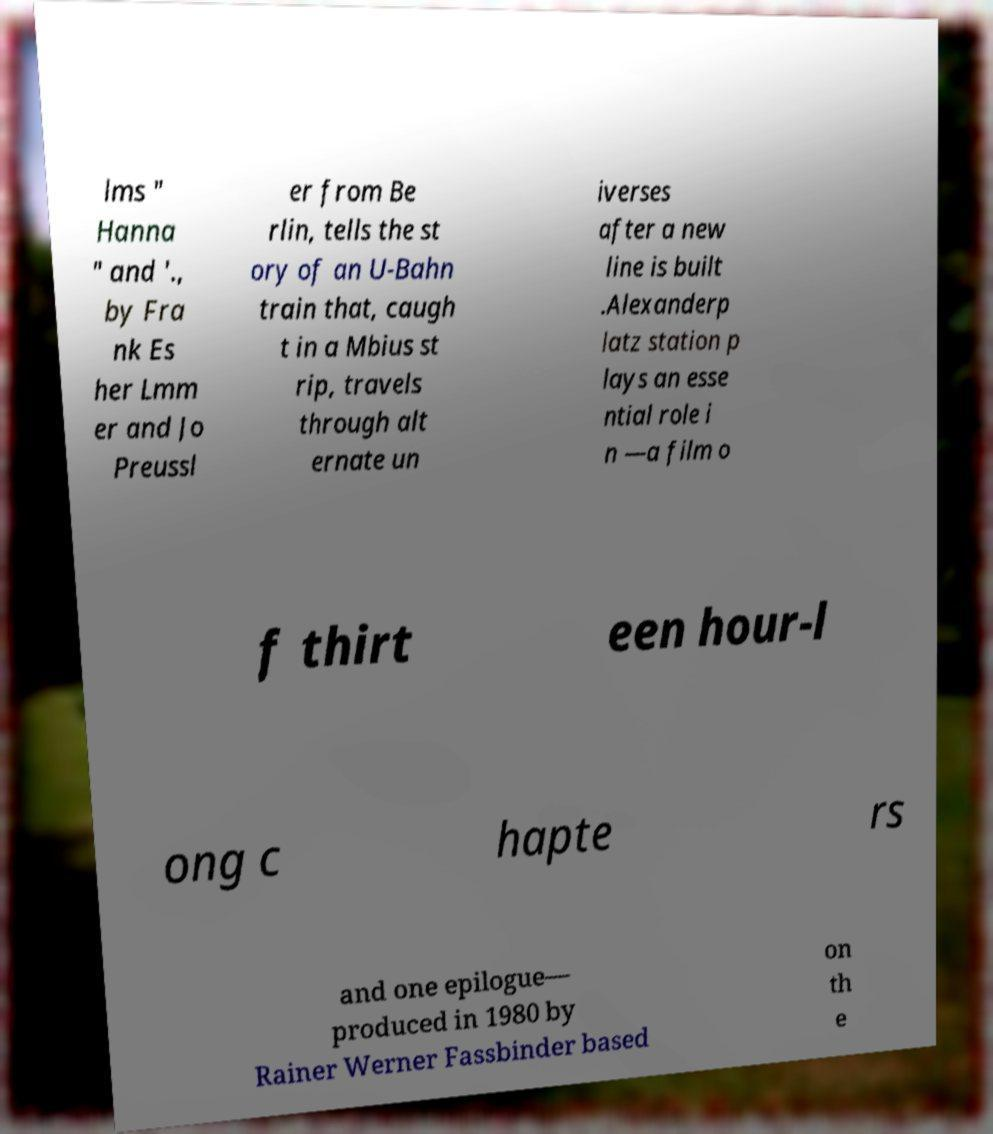There's text embedded in this image that I need extracted. Can you transcribe it verbatim? lms " Hanna " and '., by Fra nk Es her Lmm er and Jo Preussl er from Be rlin, tells the st ory of an U-Bahn train that, caugh t in a Mbius st rip, travels through alt ernate un iverses after a new line is built .Alexanderp latz station p lays an esse ntial role i n —a film o f thirt een hour-l ong c hapte rs and one epilogue— produced in 1980 by Rainer Werner Fassbinder based on th e 